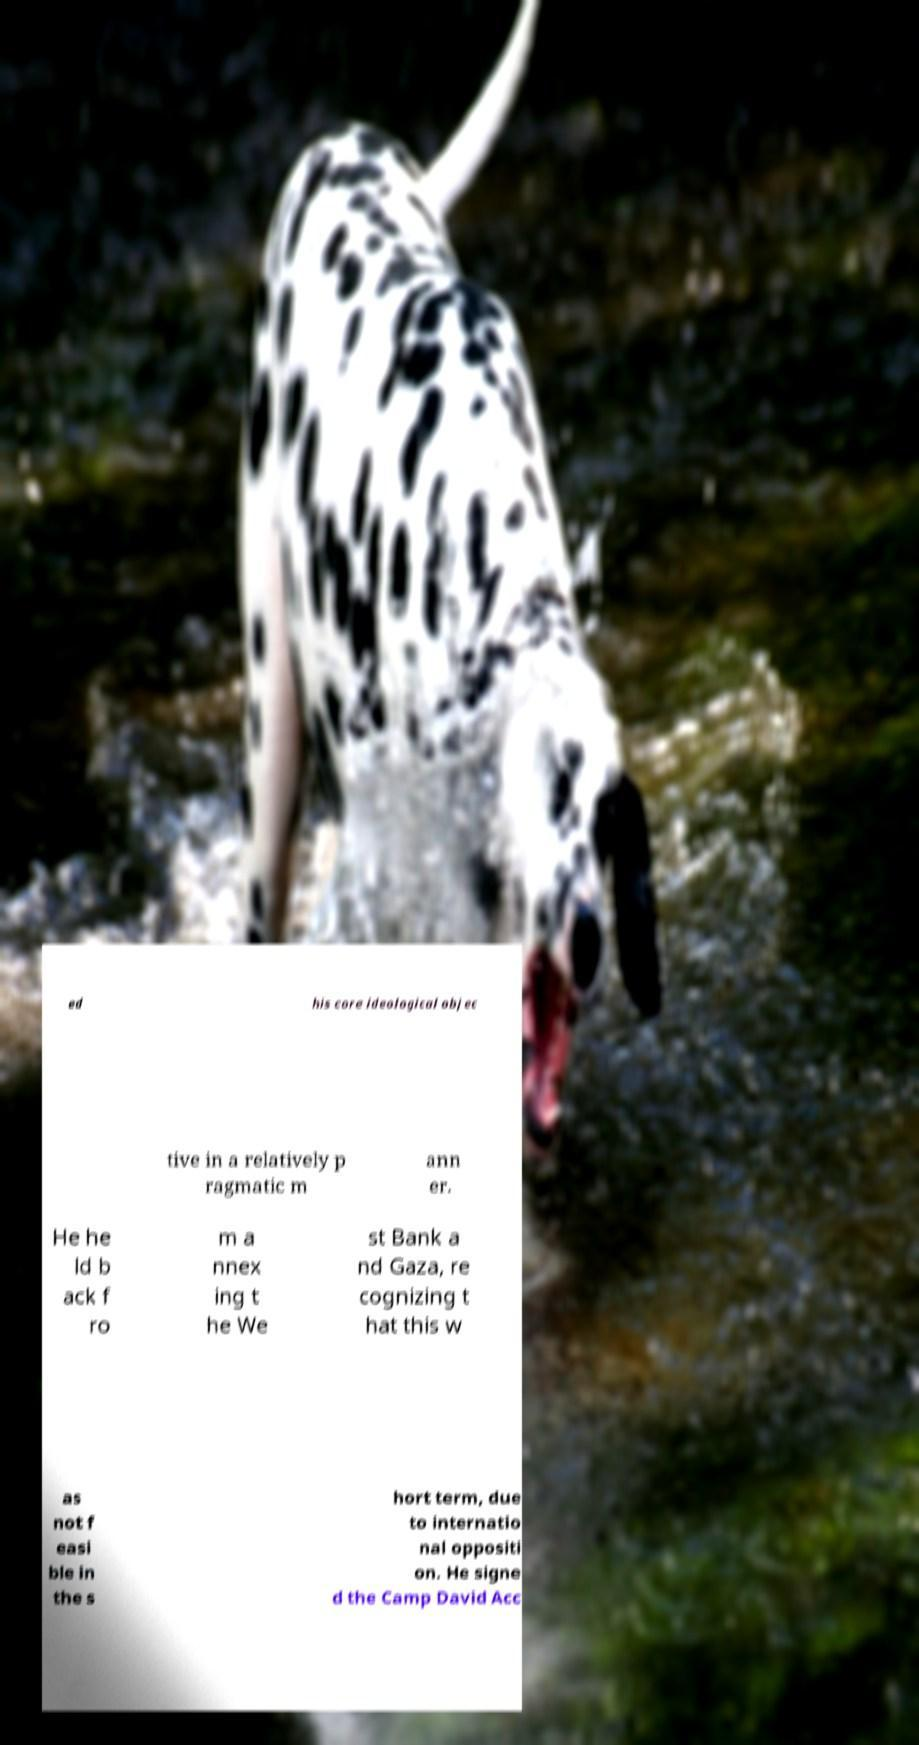For documentation purposes, I need the text within this image transcribed. Could you provide that? ed his core ideological objec tive in a relatively p ragmatic m ann er. He he ld b ack f ro m a nnex ing t he We st Bank a nd Gaza, re cognizing t hat this w as not f easi ble in the s hort term, due to internatio nal oppositi on. He signe d the Camp David Acc 